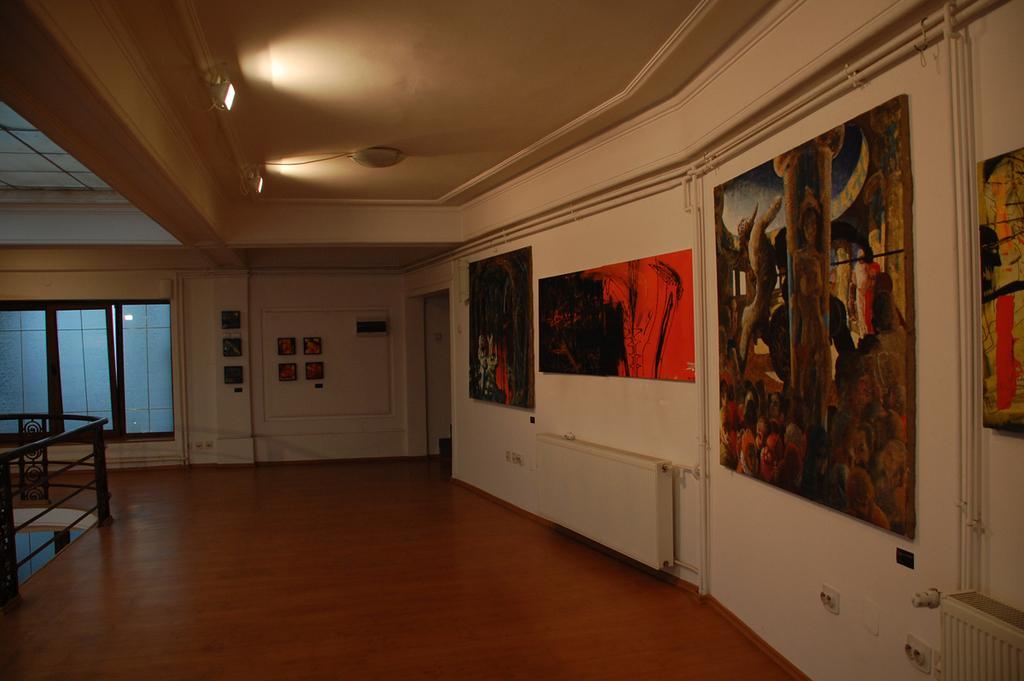How would you summarize this image in a sentence or two? This image is clicked inside a room. There are lights at the top. There are so many paintings on the wall. There are windows on the left side. 